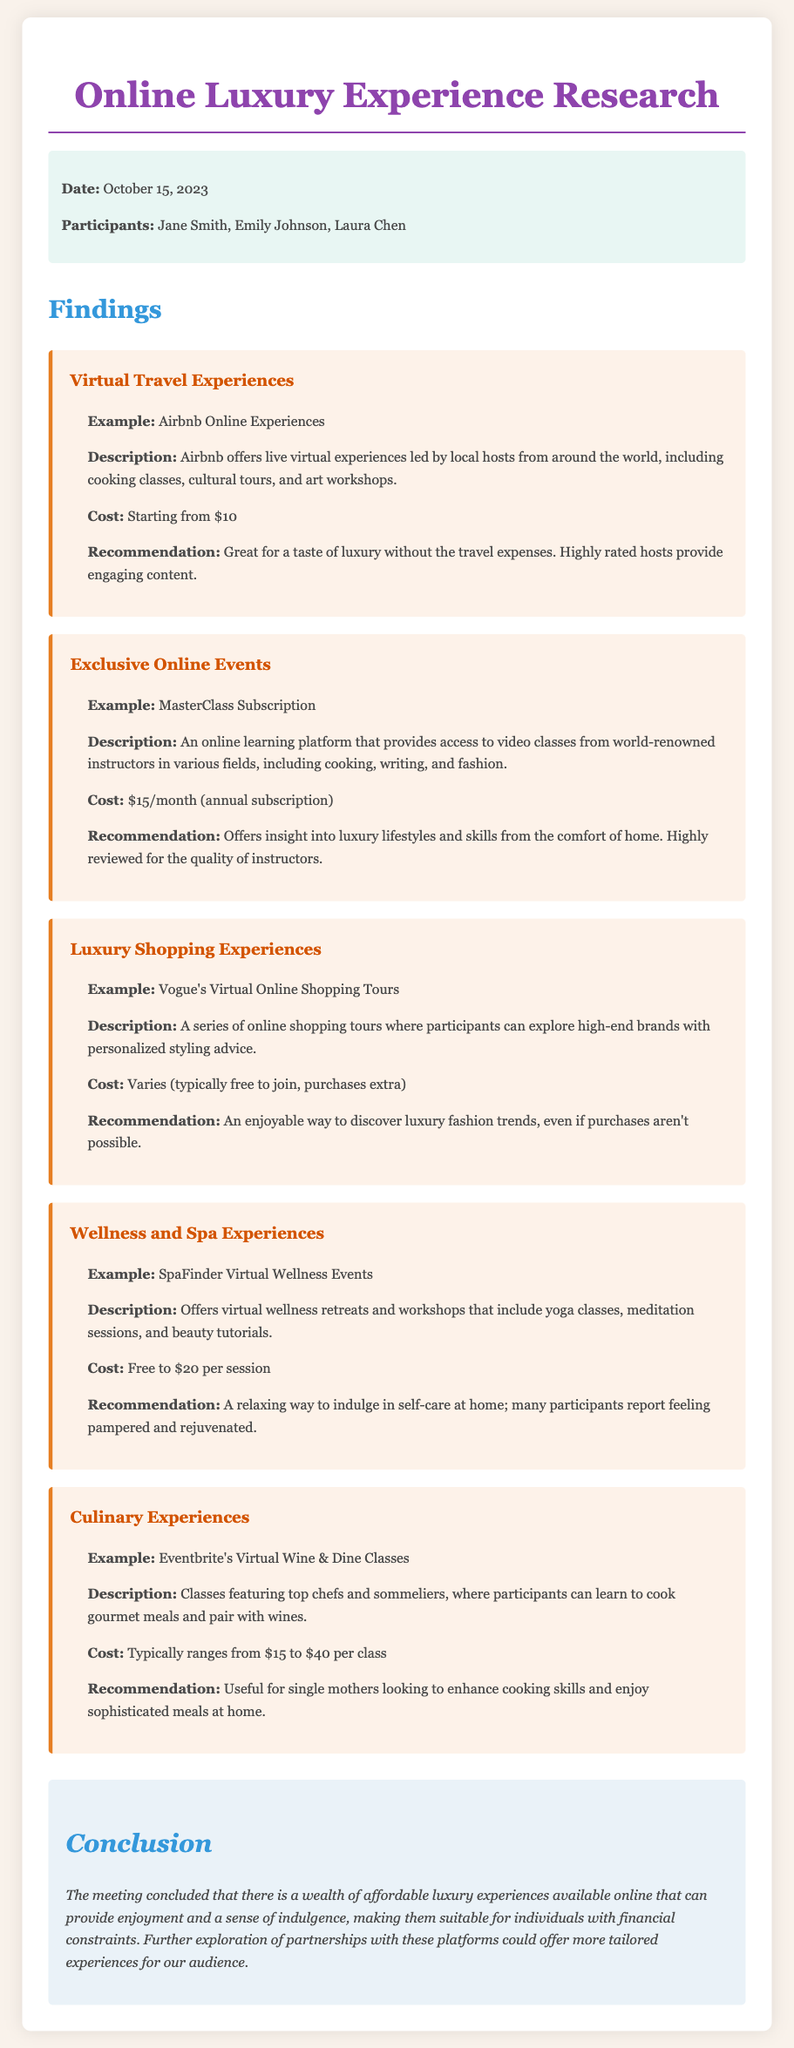What is the date of the meeting? The date of the meeting is stated in the meta section of the document.
Answer: October 15, 2023 Who are the participants in the meeting? The participants are listed in the meta section under participants.
Answer: Jane Smith, Emily Johnson, Laura Chen What is the starting cost of Airbnb Online Experiences? The cost is mentioned in the finding for Virtual Travel Experiences.
Answer: Starting from $10 What type of experiences does MasterClass provide? The description under Exclusive Online Events details the type of experiences available.
Answer: Video classes from world-renowned instructors What is the recommendation for Vogue's Virtual Online Shopping Tours? The recommendation for this luxury shopping experience is mentioned in the finding's detail.
Answer: An enjoyable way to discover luxury fashion trends What is the cost range for Eventbrite's Virtual Wine & Dine Classes? The range of costs is given in the Culinary Experiences finding.
Answer: Typically ranges from $15 to $40 per class What is the conclusion of the meeting? The conclusion summarizes the discussion about affordable luxury experiences available online.
Answer: A wealth of affordable luxury experiences available online How do virtual wellness events benefit participants? The detail in the finding for Wellness and Spa Experiences describes participant feedback.
Answer: Many participants report feeling pampered and rejuvenated 